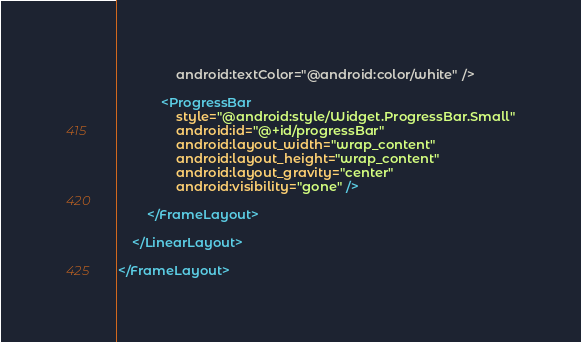<code> <loc_0><loc_0><loc_500><loc_500><_XML_>                android:textColor="@android:color/white" />

            <ProgressBar
                style="@android:style/Widget.ProgressBar.Small"
                android:id="@+id/progressBar"
                android:layout_width="wrap_content"
                android:layout_height="wrap_content"
                android:layout_gravity="center"
                android:visibility="gone" />

        </FrameLayout>

    </LinearLayout>

</FrameLayout>
</code> 